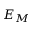<formula> <loc_0><loc_0><loc_500><loc_500>E _ { M }</formula> 